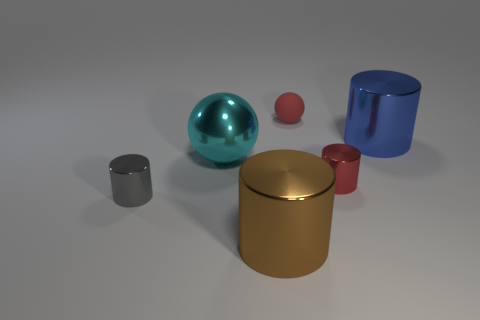Is there anything else that has the same material as the tiny red sphere?
Offer a very short reply. No. Is there anything else of the same color as the large sphere?
Offer a very short reply. No. Do the sphere to the right of the big cyan metallic thing and the small object that is to the left of the small rubber thing have the same color?
Your answer should be very brief. No. What color is the tiny metallic cylinder that is left of the brown metal object?
Provide a succinct answer. Gray. Do the sphere behind the blue thing and the large cyan ball have the same size?
Make the answer very short. No. Are there fewer small green cubes than small things?
Your answer should be very brief. Yes. How many small things are on the right side of the large brown cylinder?
Offer a terse response. 2. Does the gray thing have the same shape as the brown shiny thing?
Provide a succinct answer. Yes. What number of metal things are right of the tiny rubber ball and in front of the large sphere?
Keep it short and to the point. 1. How many objects are big metallic balls or metallic things on the left side of the large brown object?
Offer a very short reply. 2. 